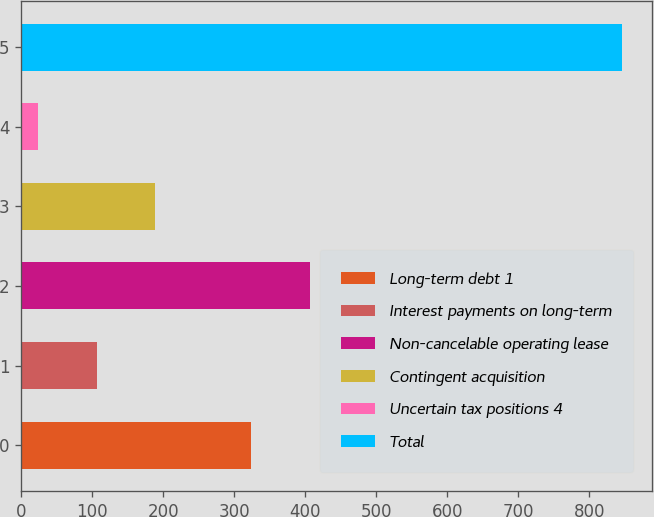Convert chart to OTSL. <chart><loc_0><loc_0><loc_500><loc_500><bar_chart><fcel>Long-term debt 1<fcel>Interest payments on long-term<fcel>Non-cancelable operating lease<fcel>Contingent acquisition<fcel>Uncertain tax positions 4<fcel>Total<nl><fcel>323.9<fcel>106.22<fcel>406.12<fcel>188.44<fcel>24<fcel>846.2<nl></chart> 